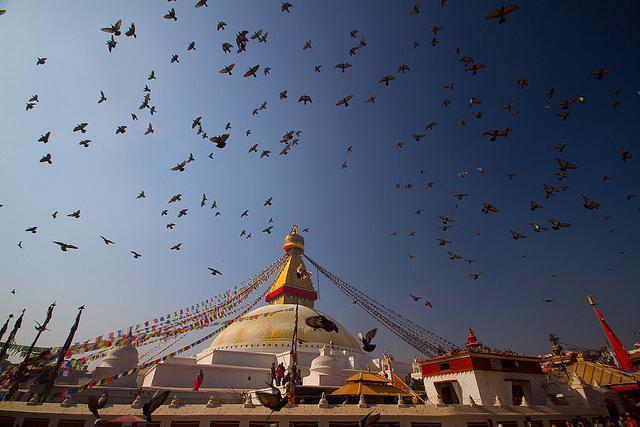How many zebras are visible?
Give a very brief answer. 0. 